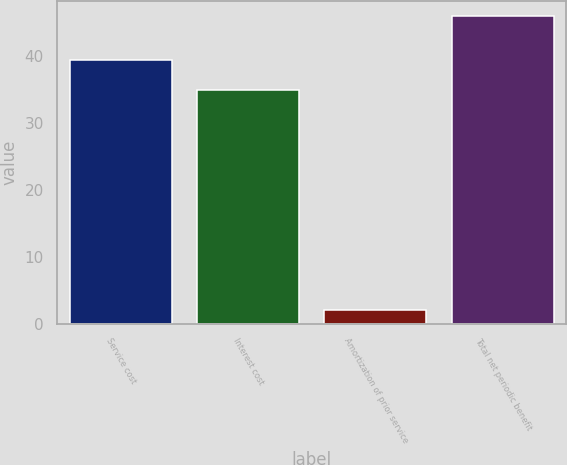<chart> <loc_0><loc_0><loc_500><loc_500><bar_chart><fcel>Service cost<fcel>Interest cost<fcel>Amortization of prior service<fcel>Total net periodic benefit<nl><fcel>39.4<fcel>35<fcel>2<fcel>46<nl></chart> 